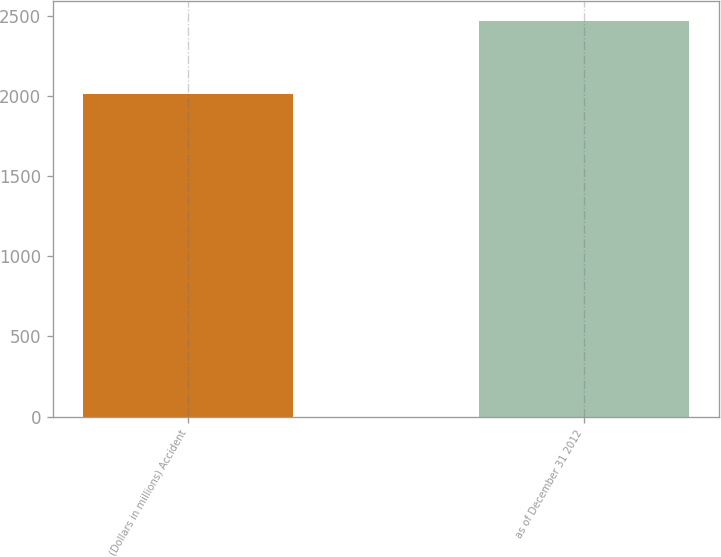Convert chart to OTSL. <chart><loc_0><loc_0><loc_500><loc_500><bar_chart><fcel>(Dollars in millions) Accident<fcel>as of December 31 2012<nl><fcel>2011<fcel>2467<nl></chart> 